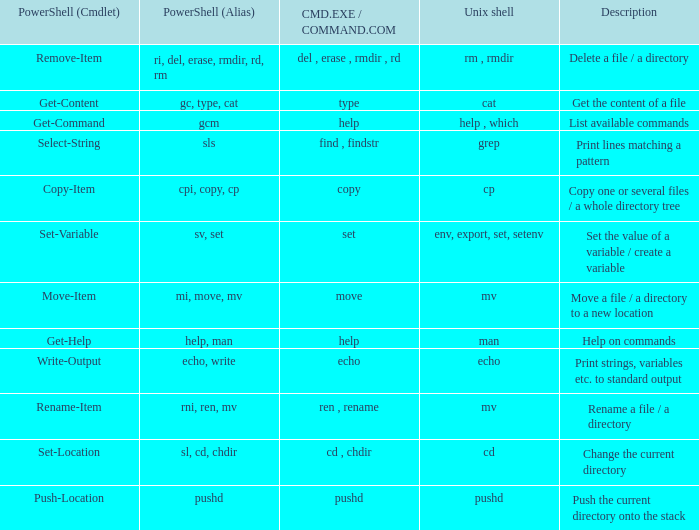What are the names of all unix shell with PowerShell (Cmdlet) of select-string? Grep. 